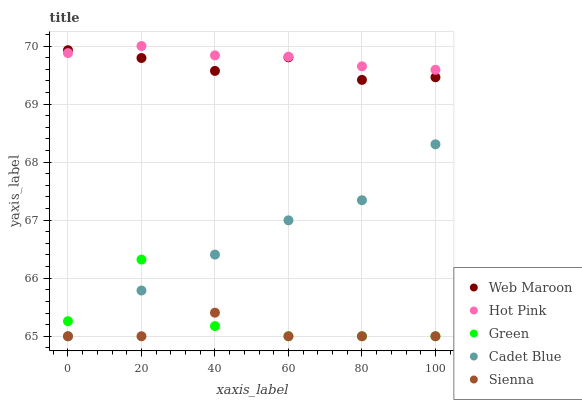Does Sienna have the minimum area under the curve?
Answer yes or no. Yes. Does Hot Pink have the maximum area under the curve?
Answer yes or no. Yes. Does Green have the minimum area under the curve?
Answer yes or no. No. Does Green have the maximum area under the curve?
Answer yes or no. No. Is Hot Pink the smoothest?
Answer yes or no. Yes. Is Green the roughest?
Answer yes or no. Yes. Is Green the smoothest?
Answer yes or no. No. Is Hot Pink the roughest?
Answer yes or no. No. Does Cadet Blue have the lowest value?
Answer yes or no. Yes. Does Hot Pink have the lowest value?
Answer yes or no. No. Does Hot Pink have the highest value?
Answer yes or no. Yes. Does Green have the highest value?
Answer yes or no. No. Is Cadet Blue less than Hot Pink?
Answer yes or no. Yes. Is Web Maroon greater than Sienna?
Answer yes or no. Yes. Does Green intersect Cadet Blue?
Answer yes or no. Yes. Is Green less than Cadet Blue?
Answer yes or no. No. Is Green greater than Cadet Blue?
Answer yes or no. No. Does Cadet Blue intersect Hot Pink?
Answer yes or no. No. 